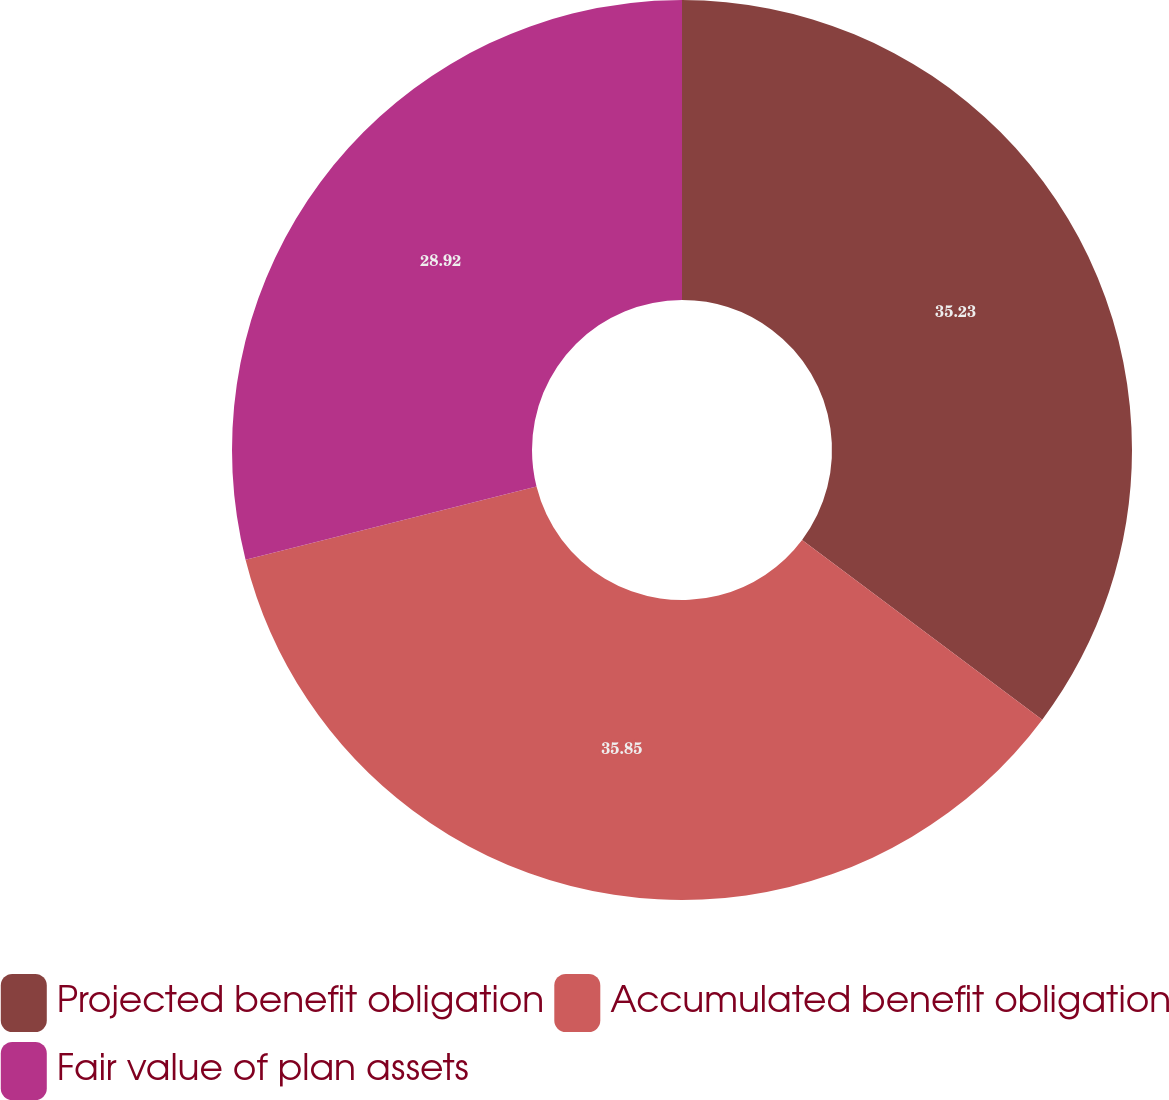Convert chart. <chart><loc_0><loc_0><loc_500><loc_500><pie_chart><fcel>Projected benefit obligation<fcel>Accumulated benefit obligation<fcel>Fair value of plan assets<nl><fcel>35.23%<fcel>35.86%<fcel>28.92%<nl></chart> 